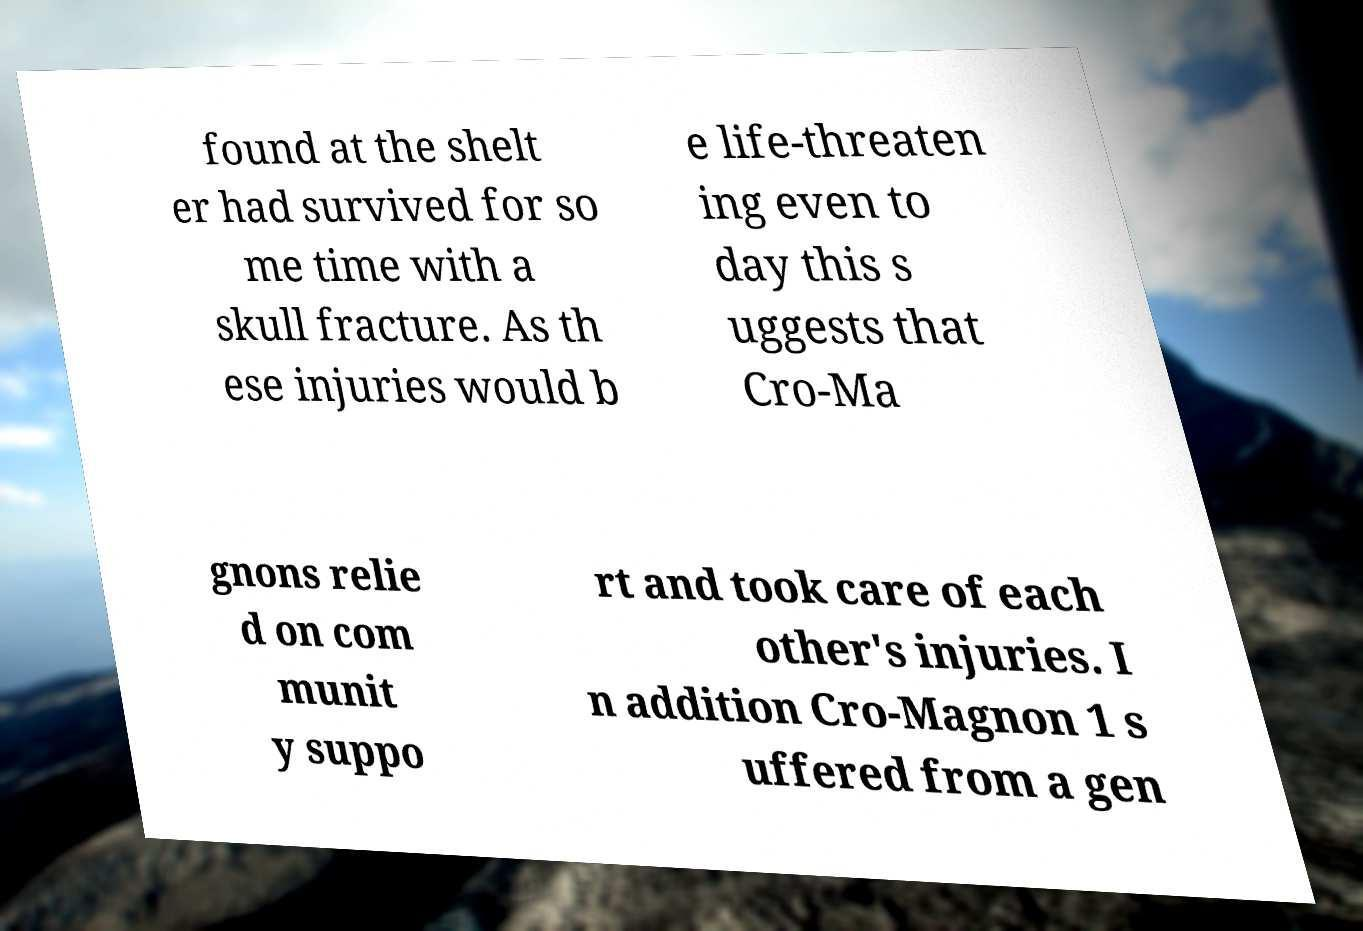I need the written content from this picture converted into text. Can you do that? found at the shelt er had survived for so me time with a skull fracture. As th ese injuries would b e life-threaten ing even to day this s uggests that Cro-Ma gnons relie d on com munit y suppo rt and took care of each other's injuries. I n addition Cro-Magnon 1 s uffered from a gen 